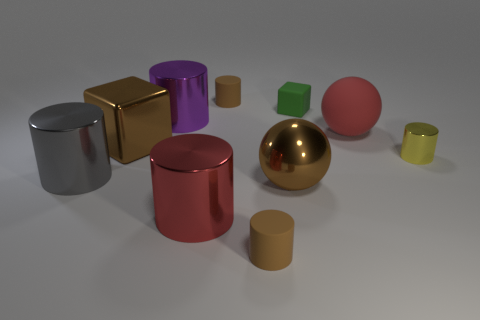There is a big purple metal thing; are there any tiny brown matte cylinders on the left side of it? No, there are no tiny brown matte cylinders on the left side of the big purple metal thing. The visible objects on the left include a red metallic cylinder and a small yellow cylinder, but none fit the description of being tiny, brown, and matte. 